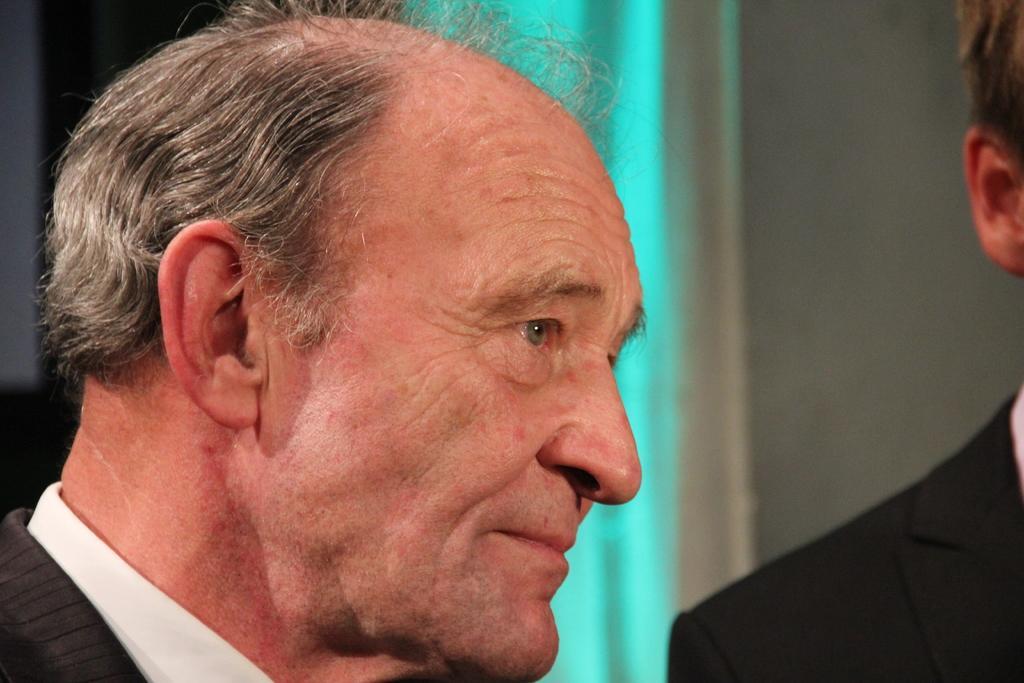Can you describe this image briefly? In this picture we can see two men where a man wore blazer and in the background we can see wall. 